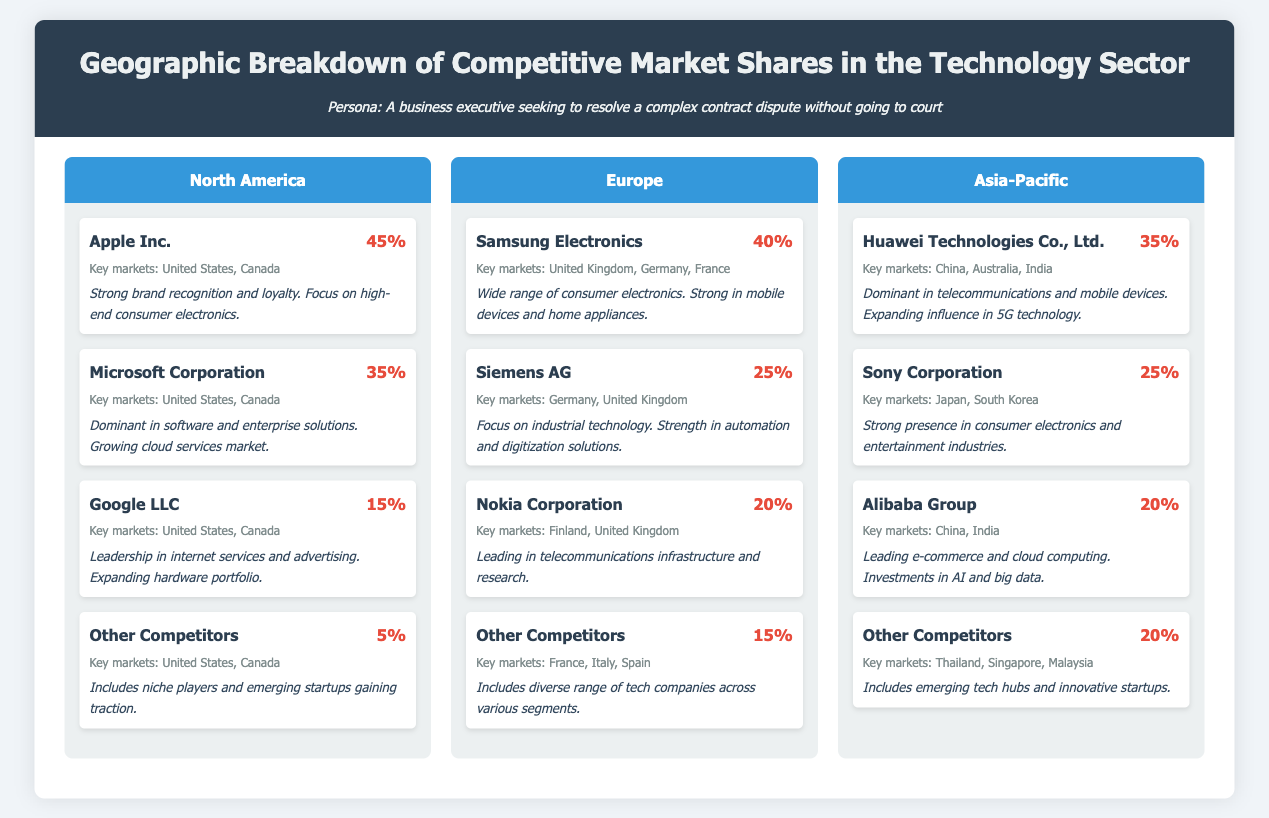What is the market share of Apple Inc. in North America? The market share of Apple Inc. is specifically stated in the document as 45%.
Answer: 45% Who is the leading company in Europe by market share? The leading company in Europe is Samsung Electronics, with a market share of 40%.
Answer: Samsung Electronics What percentage of the market is captured by Other Competitors in Asia-Pacific? The document indicates that Other Competitors hold 20% of the market in Asia-Pacific.
Answer: 20% Which company has a focus on industrial technology in Europe? Siemens AG is explicitly mentioned as having a focus on industrial technology.
Answer: Siemens AG What key markets does Google LLC serve? The key markets for Google LLC are provided in the document as the United States and Canada.
Answer: United States, Canada In which region does Huawei Technologies Co., Ltd. have a market share of 35%? The document specifies that Huawei Technologies Co., Ltd. has a market share of 35% in the Asia-Pacific region.
Answer: Asia-Pacific How many companies are listed for market shares in North America? There are four companies listed in the North America section of the document.
Answer: Four Which company is noted for its strong presence in consumer electronics and entertainment in Asia-Pacific? The document highlights Sony Corporation for its strong presence in those industries.
Answer: Sony Corporation What is the total market share percentage accounted for by Microsoft Corporation and Google LLC combined in North America? The combined market share percentage for Microsoft Corporation (35%) and Google LLC (15%) is calculated as 50%.
Answer: 50% 